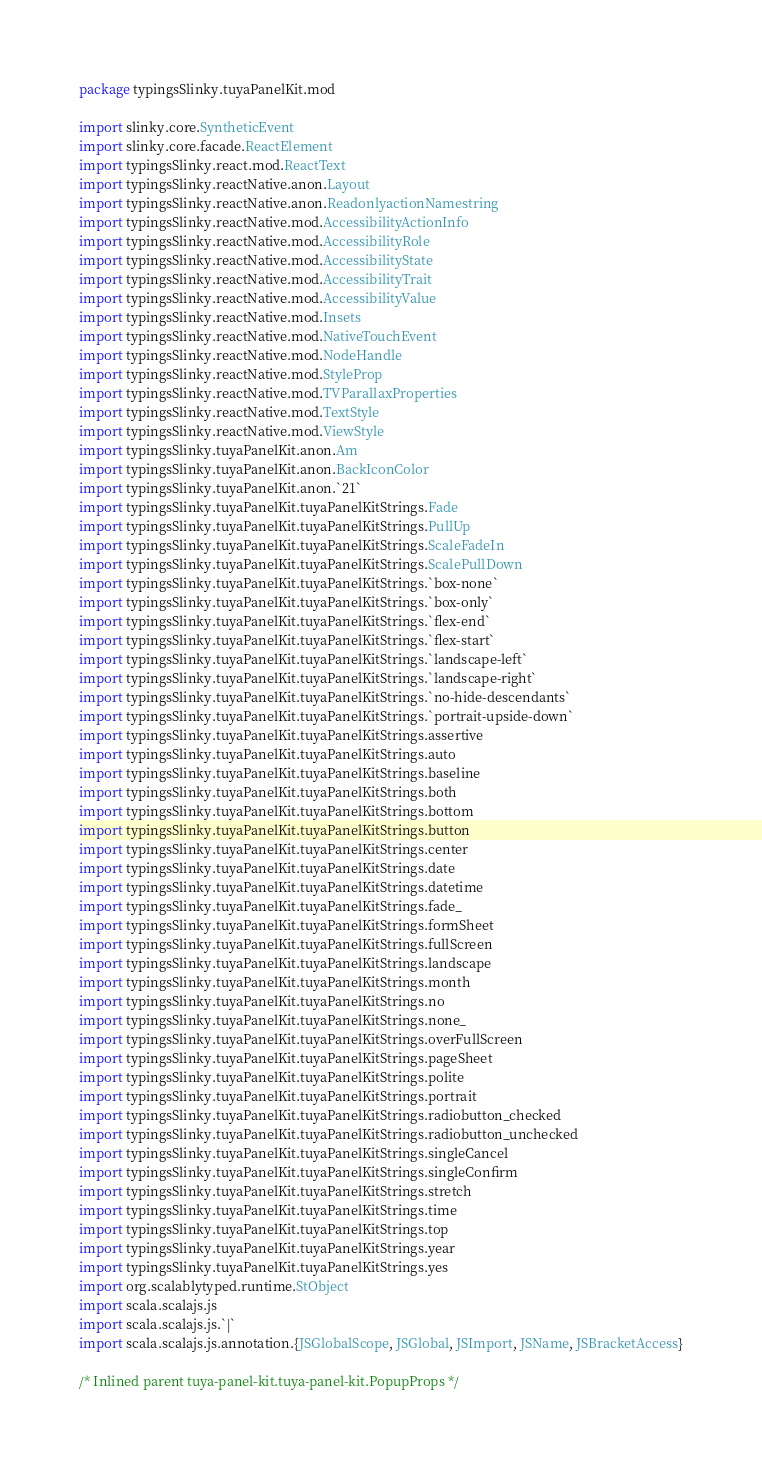<code> <loc_0><loc_0><loc_500><loc_500><_Scala_>package typingsSlinky.tuyaPanelKit.mod

import slinky.core.SyntheticEvent
import slinky.core.facade.ReactElement
import typingsSlinky.react.mod.ReactText
import typingsSlinky.reactNative.anon.Layout
import typingsSlinky.reactNative.anon.ReadonlyactionNamestring
import typingsSlinky.reactNative.mod.AccessibilityActionInfo
import typingsSlinky.reactNative.mod.AccessibilityRole
import typingsSlinky.reactNative.mod.AccessibilityState
import typingsSlinky.reactNative.mod.AccessibilityTrait
import typingsSlinky.reactNative.mod.AccessibilityValue
import typingsSlinky.reactNative.mod.Insets
import typingsSlinky.reactNative.mod.NativeTouchEvent
import typingsSlinky.reactNative.mod.NodeHandle
import typingsSlinky.reactNative.mod.StyleProp
import typingsSlinky.reactNative.mod.TVParallaxProperties
import typingsSlinky.reactNative.mod.TextStyle
import typingsSlinky.reactNative.mod.ViewStyle
import typingsSlinky.tuyaPanelKit.anon.Am
import typingsSlinky.tuyaPanelKit.anon.BackIconColor
import typingsSlinky.tuyaPanelKit.anon.`21`
import typingsSlinky.tuyaPanelKit.tuyaPanelKitStrings.Fade
import typingsSlinky.tuyaPanelKit.tuyaPanelKitStrings.PullUp
import typingsSlinky.tuyaPanelKit.tuyaPanelKitStrings.ScaleFadeIn
import typingsSlinky.tuyaPanelKit.tuyaPanelKitStrings.ScalePullDown
import typingsSlinky.tuyaPanelKit.tuyaPanelKitStrings.`box-none`
import typingsSlinky.tuyaPanelKit.tuyaPanelKitStrings.`box-only`
import typingsSlinky.tuyaPanelKit.tuyaPanelKitStrings.`flex-end`
import typingsSlinky.tuyaPanelKit.tuyaPanelKitStrings.`flex-start`
import typingsSlinky.tuyaPanelKit.tuyaPanelKitStrings.`landscape-left`
import typingsSlinky.tuyaPanelKit.tuyaPanelKitStrings.`landscape-right`
import typingsSlinky.tuyaPanelKit.tuyaPanelKitStrings.`no-hide-descendants`
import typingsSlinky.tuyaPanelKit.tuyaPanelKitStrings.`portrait-upside-down`
import typingsSlinky.tuyaPanelKit.tuyaPanelKitStrings.assertive
import typingsSlinky.tuyaPanelKit.tuyaPanelKitStrings.auto
import typingsSlinky.tuyaPanelKit.tuyaPanelKitStrings.baseline
import typingsSlinky.tuyaPanelKit.tuyaPanelKitStrings.both
import typingsSlinky.tuyaPanelKit.tuyaPanelKitStrings.bottom
import typingsSlinky.tuyaPanelKit.tuyaPanelKitStrings.button
import typingsSlinky.tuyaPanelKit.tuyaPanelKitStrings.center
import typingsSlinky.tuyaPanelKit.tuyaPanelKitStrings.date
import typingsSlinky.tuyaPanelKit.tuyaPanelKitStrings.datetime
import typingsSlinky.tuyaPanelKit.tuyaPanelKitStrings.fade_
import typingsSlinky.tuyaPanelKit.tuyaPanelKitStrings.formSheet
import typingsSlinky.tuyaPanelKit.tuyaPanelKitStrings.fullScreen
import typingsSlinky.tuyaPanelKit.tuyaPanelKitStrings.landscape
import typingsSlinky.tuyaPanelKit.tuyaPanelKitStrings.month
import typingsSlinky.tuyaPanelKit.tuyaPanelKitStrings.no
import typingsSlinky.tuyaPanelKit.tuyaPanelKitStrings.none_
import typingsSlinky.tuyaPanelKit.tuyaPanelKitStrings.overFullScreen
import typingsSlinky.tuyaPanelKit.tuyaPanelKitStrings.pageSheet
import typingsSlinky.tuyaPanelKit.tuyaPanelKitStrings.polite
import typingsSlinky.tuyaPanelKit.tuyaPanelKitStrings.portrait
import typingsSlinky.tuyaPanelKit.tuyaPanelKitStrings.radiobutton_checked
import typingsSlinky.tuyaPanelKit.tuyaPanelKitStrings.radiobutton_unchecked
import typingsSlinky.tuyaPanelKit.tuyaPanelKitStrings.singleCancel
import typingsSlinky.tuyaPanelKit.tuyaPanelKitStrings.singleConfirm
import typingsSlinky.tuyaPanelKit.tuyaPanelKitStrings.stretch
import typingsSlinky.tuyaPanelKit.tuyaPanelKitStrings.time
import typingsSlinky.tuyaPanelKit.tuyaPanelKitStrings.top
import typingsSlinky.tuyaPanelKit.tuyaPanelKitStrings.year
import typingsSlinky.tuyaPanelKit.tuyaPanelKitStrings.yes
import org.scalablytyped.runtime.StObject
import scala.scalajs.js
import scala.scalajs.js.`|`
import scala.scalajs.js.annotation.{JSGlobalScope, JSGlobal, JSImport, JSName, JSBracketAccess}

/* Inlined parent tuya-panel-kit.tuya-panel-kit.PopupProps */</code> 